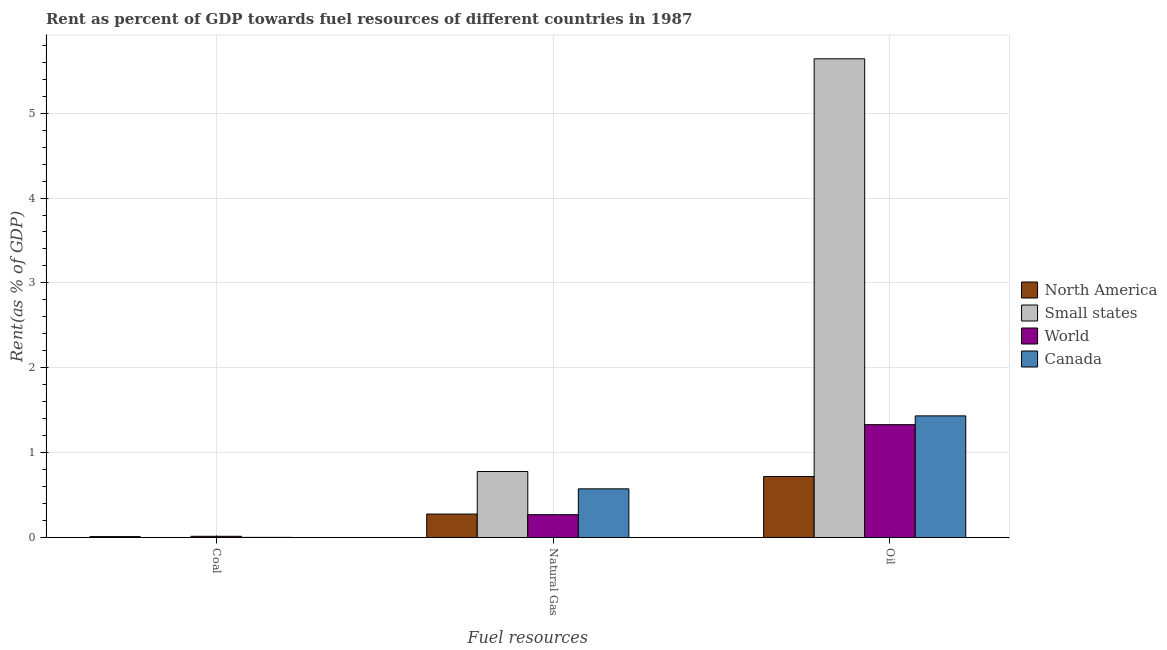How many different coloured bars are there?
Your answer should be very brief. 4. How many bars are there on the 1st tick from the right?
Offer a very short reply. 4. What is the label of the 2nd group of bars from the left?
Provide a short and direct response. Natural Gas. What is the rent towards oil in Small states?
Offer a very short reply. 5.64. Across all countries, what is the maximum rent towards natural gas?
Your response must be concise. 0.78. Across all countries, what is the minimum rent towards coal?
Your response must be concise. 2.2843202919127e-5. In which country was the rent towards natural gas maximum?
Ensure brevity in your answer.  Small states. In which country was the rent towards coal minimum?
Make the answer very short. Small states. What is the total rent towards coal in the graph?
Your answer should be very brief. 0.03. What is the difference between the rent towards coal in Canada and that in Small states?
Ensure brevity in your answer.  0. What is the difference between the rent towards natural gas in North America and the rent towards oil in World?
Your response must be concise. -1.05. What is the average rent towards coal per country?
Offer a terse response. 0.01. What is the difference between the rent towards coal and rent towards natural gas in Canada?
Give a very brief answer. -0.57. What is the ratio of the rent towards oil in Canada to that in North America?
Provide a succinct answer. 1.99. Is the rent towards coal in Canada less than that in North America?
Make the answer very short. Yes. Is the difference between the rent towards oil in North America and Small states greater than the difference between the rent towards coal in North America and Small states?
Ensure brevity in your answer.  No. What is the difference between the highest and the second highest rent towards coal?
Give a very brief answer. 0. What is the difference between the highest and the lowest rent towards coal?
Offer a terse response. 0.01. In how many countries, is the rent towards oil greater than the average rent towards oil taken over all countries?
Keep it short and to the point. 1. Is the sum of the rent towards coal in Canada and World greater than the maximum rent towards oil across all countries?
Provide a short and direct response. No. Is it the case that in every country, the sum of the rent towards coal and rent towards natural gas is greater than the rent towards oil?
Provide a short and direct response. No. How many bars are there?
Provide a succinct answer. 12. Does the graph contain any zero values?
Provide a succinct answer. No. How many legend labels are there?
Ensure brevity in your answer.  4. What is the title of the graph?
Provide a succinct answer. Rent as percent of GDP towards fuel resources of different countries in 1987. What is the label or title of the X-axis?
Provide a succinct answer. Fuel resources. What is the label or title of the Y-axis?
Your answer should be very brief. Rent(as % of GDP). What is the Rent(as % of GDP) in North America in Coal?
Provide a short and direct response. 0.01. What is the Rent(as % of GDP) of Small states in Coal?
Keep it short and to the point. 2.2843202919127e-5. What is the Rent(as % of GDP) in World in Coal?
Your response must be concise. 0.01. What is the Rent(as % of GDP) of Canada in Coal?
Your answer should be compact. 0. What is the Rent(as % of GDP) of North America in Natural Gas?
Ensure brevity in your answer.  0.28. What is the Rent(as % of GDP) of Small states in Natural Gas?
Offer a very short reply. 0.78. What is the Rent(as % of GDP) in World in Natural Gas?
Offer a terse response. 0.27. What is the Rent(as % of GDP) of Canada in Natural Gas?
Offer a very short reply. 0.57. What is the Rent(as % of GDP) in North America in Oil?
Keep it short and to the point. 0.72. What is the Rent(as % of GDP) of Small states in Oil?
Offer a terse response. 5.64. What is the Rent(as % of GDP) of World in Oil?
Give a very brief answer. 1.33. What is the Rent(as % of GDP) of Canada in Oil?
Provide a succinct answer. 1.43. Across all Fuel resources, what is the maximum Rent(as % of GDP) of North America?
Keep it short and to the point. 0.72. Across all Fuel resources, what is the maximum Rent(as % of GDP) of Small states?
Offer a very short reply. 5.64. Across all Fuel resources, what is the maximum Rent(as % of GDP) of World?
Your response must be concise. 1.33. Across all Fuel resources, what is the maximum Rent(as % of GDP) in Canada?
Provide a short and direct response. 1.43. Across all Fuel resources, what is the minimum Rent(as % of GDP) in North America?
Offer a terse response. 0.01. Across all Fuel resources, what is the minimum Rent(as % of GDP) of Small states?
Provide a short and direct response. 2.2843202919127e-5. Across all Fuel resources, what is the minimum Rent(as % of GDP) in World?
Make the answer very short. 0.01. Across all Fuel resources, what is the minimum Rent(as % of GDP) in Canada?
Your answer should be compact. 0. What is the total Rent(as % of GDP) in North America in the graph?
Make the answer very short. 1.01. What is the total Rent(as % of GDP) of Small states in the graph?
Offer a terse response. 6.42. What is the total Rent(as % of GDP) in World in the graph?
Your response must be concise. 1.61. What is the total Rent(as % of GDP) of Canada in the graph?
Keep it short and to the point. 2.01. What is the difference between the Rent(as % of GDP) in North America in Coal and that in Natural Gas?
Your response must be concise. -0.27. What is the difference between the Rent(as % of GDP) in Small states in Coal and that in Natural Gas?
Provide a succinct answer. -0.78. What is the difference between the Rent(as % of GDP) of World in Coal and that in Natural Gas?
Keep it short and to the point. -0.25. What is the difference between the Rent(as % of GDP) of Canada in Coal and that in Natural Gas?
Your answer should be compact. -0.57. What is the difference between the Rent(as % of GDP) in North America in Coal and that in Oil?
Offer a terse response. -0.71. What is the difference between the Rent(as % of GDP) in Small states in Coal and that in Oil?
Provide a succinct answer. -5.64. What is the difference between the Rent(as % of GDP) in World in Coal and that in Oil?
Keep it short and to the point. -1.32. What is the difference between the Rent(as % of GDP) of Canada in Coal and that in Oil?
Your response must be concise. -1.43. What is the difference between the Rent(as % of GDP) of North America in Natural Gas and that in Oil?
Offer a very short reply. -0.44. What is the difference between the Rent(as % of GDP) of Small states in Natural Gas and that in Oil?
Ensure brevity in your answer.  -4.86. What is the difference between the Rent(as % of GDP) of World in Natural Gas and that in Oil?
Your answer should be compact. -1.06. What is the difference between the Rent(as % of GDP) in Canada in Natural Gas and that in Oil?
Ensure brevity in your answer.  -0.86. What is the difference between the Rent(as % of GDP) in North America in Coal and the Rent(as % of GDP) in Small states in Natural Gas?
Keep it short and to the point. -0.77. What is the difference between the Rent(as % of GDP) in North America in Coal and the Rent(as % of GDP) in World in Natural Gas?
Provide a short and direct response. -0.26. What is the difference between the Rent(as % of GDP) of North America in Coal and the Rent(as % of GDP) of Canada in Natural Gas?
Provide a short and direct response. -0.56. What is the difference between the Rent(as % of GDP) in Small states in Coal and the Rent(as % of GDP) in World in Natural Gas?
Your answer should be compact. -0.27. What is the difference between the Rent(as % of GDP) in Small states in Coal and the Rent(as % of GDP) in Canada in Natural Gas?
Provide a short and direct response. -0.57. What is the difference between the Rent(as % of GDP) in World in Coal and the Rent(as % of GDP) in Canada in Natural Gas?
Provide a succinct answer. -0.56. What is the difference between the Rent(as % of GDP) of North America in Coal and the Rent(as % of GDP) of Small states in Oil?
Your answer should be compact. -5.63. What is the difference between the Rent(as % of GDP) of North America in Coal and the Rent(as % of GDP) of World in Oil?
Your answer should be compact. -1.32. What is the difference between the Rent(as % of GDP) in North America in Coal and the Rent(as % of GDP) in Canada in Oil?
Ensure brevity in your answer.  -1.42. What is the difference between the Rent(as % of GDP) of Small states in Coal and the Rent(as % of GDP) of World in Oil?
Your answer should be very brief. -1.33. What is the difference between the Rent(as % of GDP) of Small states in Coal and the Rent(as % of GDP) of Canada in Oil?
Ensure brevity in your answer.  -1.43. What is the difference between the Rent(as % of GDP) in World in Coal and the Rent(as % of GDP) in Canada in Oil?
Offer a very short reply. -1.42. What is the difference between the Rent(as % of GDP) in North America in Natural Gas and the Rent(as % of GDP) in Small states in Oil?
Your response must be concise. -5.36. What is the difference between the Rent(as % of GDP) in North America in Natural Gas and the Rent(as % of GDP) in World in Oil?
Offer a very short reply. -1.05. What is the difference between the Rent(as % of GDP) in North America in Natural Gas and the Rent(as % of GDP) in Canada in Oil?
Keep it short and to the point. -1.16. What is the difference between the Rent(as % of GDP) of Small states in Natural Gas and the Rent(as % of GDP) of World in Oil?
Offer a terse response. -0.55. What is the difference between the Rent(as % of GDP) in Small states in Natural Gas and the Rent(as % of GDP) in Canada in Oil?
Ensure brevity in your answer.  -0.66. What is the difference between the Rent(as % of GDP) in World in Natural Gas and the Rent(as % of GDP) in Canada in Oil?
Your response must be concise. -1.16. What is the average Rent(as % of GDP) in North America per Fuel resources?
Keep it short and to the point. 0.34. What is the average Rent(as % of GDP) in Small states per Fuel resources?
Provide a short and direct response. 2.14. What is the average Rent(as % of GDP) in World per Fuel resources?
Provide a short and direct response. 0.54. What is the average Rent(as % of GDP) of Canada per Fuel resources?
Provide a succinct answer. 0.67. What is the difference between the Rent(as % of GDP) of North America and Rent(as % of GDP) of Small states in Coal?
Offer a terse response. 0.01. What is the difference between the Rent(as % of GDP) in North America and Rent(as % of GDP) in World in Coal?
Keep it short and to the point. -0. What is the difference between the Rent(as % of GDP) in North America and Rent(as % of GDP) in Canada in Coal?
Offer a very short reply. 0.01. What is the difference between the Rent(as % of GDP) in Small states and Rent(as % of GDP) in World in Coal?
Ensure brevity in your answer.  -0.01. What is the difference between the Rent(as % of GDP) of Small states and Rent(as % of GDP) of Canada in Coal?
Your answer should be compact. -0. What is the difference between the Rent(as % of GDP) in World and Rent(as % of GDP) in Canada in Coal?
Offer a terse response. 0.01. What is the difference between the Rent(as % of GDP) of North America and Rent(as % of GDP) of Small states in Natural Gas?
Provide a succinct answer. -0.5. What is the difference between the Rent(as % of GDP) in North America and Rent(as % of GDP) in World in Natural Gas?
Your answer should be very brief. 0.01. What is the difference between the Rent(as % of GDP) of North America and Rent(as % of GDP) of Canada in Natural Gas?
Your response must be concise. -0.3. What is the difference between the Rent(as % of GDP) of Small states and Rent(as % of GDP) of World in Natural Gas?
Keep it short and to the point. 0.51. What is the difference between the Rent(as % of GDP) in Small states and Rent(as % of GDP) in Canada in Natural Gas?
Give a very brief answer. 0.2. What is the difference between the Rent(as % of GDP) of World and Rent(as % of GDP) of Canada in Natural Gas?
Your answer should be very brief. -0.3. What is the difference between the Rent(as % of GDP) of North America and Rent(as % of GDP) of Small states in Oil?
Provide a short and direct response. -4.92. What is the difference between the Rent(as % of GDP) in North America and Rent(as % of GDP) in World in Oil?
Offer a very short reply. -0.61. What is the difference between the Rent(as % of GDP) of North America and Rent(as % of GDP) of Canada in Oil?
Offer a very short reply. -0.71. What is the difference between the Rent(as % of GDP) of Small states and Rent(as % of GDP) of World in Oil?
Offer a very short reply. 4.31. What is the difference between the Rent(as % of GDP) in Small states and Rent(as % of GDP) in Canada in Oil?
Give a very brief answer. 4.21. What is the difference between the Rent(as % of GDP) of World and Rent(as % of GDP) of Canada in Oil?
Give a very brief answer. -0.1. What is the ratio of the Rent(as % of GDP) in North America in Coal to that in Natural Gas?
Provide a short and direct response. 0.04. What is the ratio of the Rent(as % of GDP) in World in Coal to that in Natural Gas?
Provide a short and direct response. 0.05. What is the ratio of the Rent(as % of GDP) in Canada in Coal to that in Natural Gas?
Keep it short and to the point. 0. What is the ratio of the Rent(as % of GDP) of North America in Coal to that in Oil?
Provide a succinct answer. 0.01. What is the ratio of the Rent(as % of GDP) in World in Coal to that in Oil?
Provide a succinct answer. 0.01. What is the ratio of the Rent(as % of GDP) in Canada in Coal to that in Oil?
Offer a very short reply. 0. What is the ratio of the Rent(as % of GDP) of North America in Natural Gas to that in Oil?
Provide a succinct answer. 0.38. What is the ratio of the Rent(as % of GDP) in Small states in Natural Gas to that in Oil?
Make the answer very short. 0.14. What is the ratio of the Rent(as % of GDP) of World in Natural Gas to that in Oil?
Provide a short and direct response. 0.2. What is the ratio of the Rent(as % of GDP) in Canada in Natural Gas to that in Oil?
Make the answer very short. 0.4. What is the difference between the highest and the second highest Rent(as % of GDP) of North America?
Provide a short and direct response. 0.44. What is the difference between the highest and the second highest Rent(as % of GDP) of Small states?
Give a very brief answer. 4.86. What is the difference between the highest and the second highest Rent(as % of GDP) in World?
Make the answer very short. 1.06. What is the difference between the highest and the second highest Rent(as % of GDP) in Canada?
Offer a very short reply. 0.86. What is the difference between the highest and the lowest Rent(as % of GDP) in North America?
Provide a succinct answer. 0.71. What is the difference between the highest and the lowest Rent(as % of GDP) in Small states?
Offer a very short reply. 5.64. What is the difference between the highest and the lowest Rent(as % of GDP) of World?
Make the answer very short. 1.32. What is the difference between the highest and the lowest Rent(as % of GDP) of Canada?
Offer a very short reply. 1.43. 